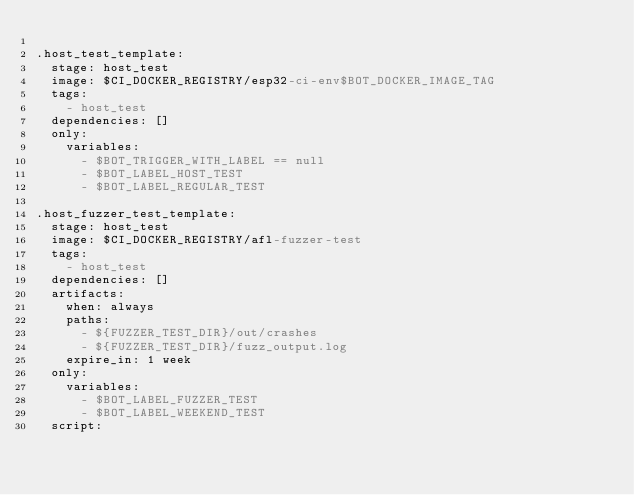Convert code to text. <code><loc_0><loc_0><loc_500><loc_500><_YAML_>
.host_test_template:
  stage: host_test
  image: $CI_DOCKER_REGISTRY/esp32-ci-env$BOT_DOCKER_IMAGE_TAG
  tags:
    - host_test
  dependencies: []
  only:
    variables:
      - $BOT_TRIGGER_WITH_LABEL == null
      - $BOT_LABEL_HOST_TEST
      - $BOT_LABEL_REGULAR_TEST

.host_fuzzer_test_template:
  stage: host_test
  image: $CI_DOCKER_REGISTRY/afl-fuzzer-test
  tags:
    - host_test
  dependencies: []
  artifacts:
    when: always
    paths:
      - ${FUZZER_TEST_DIR}/out/crashes
      - ${FUZZER_TEST_DIR}/fuzz_output.log
    expire_in: 1 week
  only:
    variables:
      - $BOT_LABEL_FUZZER_TEST
      - $BOT_LABEL_WEEKEND_TEST
  script:</code> 